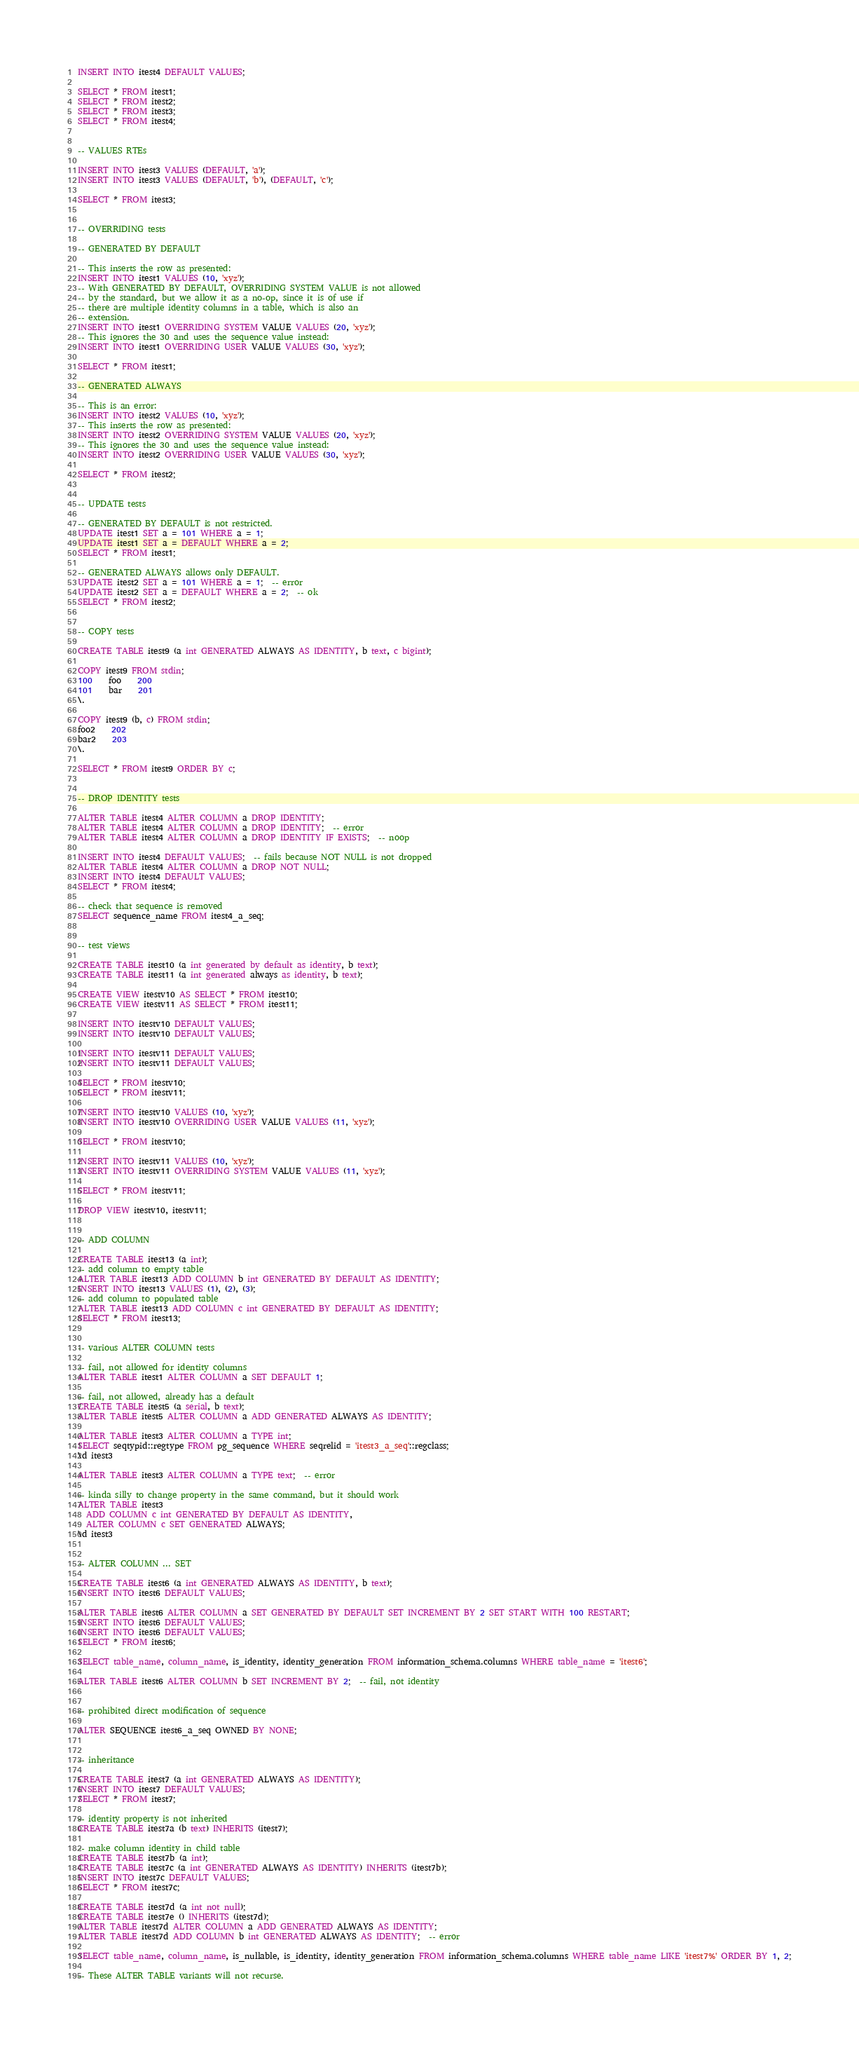<code> <loc_0><loc_0><loc_500><loc_500><_SQL_>INSERT INTO itest4 DEFAULT VALUES;

SELECT * FROM itest1;
SELECT * FROM itest2;
SELECT * FROM itest3;
SELECT * FROM itest4;


-- VALUES RTEs

INSERT INTO itest3 VALUES (DEFAULT, 'a');
INSERT INTO itest3 VALUES (DEFAULT, 'b'), (DEFAULT, 'c');

SELECT * FROM itest3;


-- OVERRIDING tests

-- GENERATED BY DEFAULT

-- This inserts the row as presented:
INSERT INTO itest1 VALUES (10, 'xyz');
-- With GENERATED BY DEFAULT, OVERRIDING SYSTEM VALUE is not allowed
-- by the standard, but we allow it as a no-op, since it is of use if
-- there are multiple identity columns in a table, which is also an
-- extension.
INSERT INTO itest1 OVERRIDING SYSTEM VALUE VALUES (20, 'xyz');
-- This ignores the 30 and uses the sequence value instead:
INSERT INTO itest1 OVERRIDING USER VALUE VALUES (30, 'xyz');

SELECT * FROM itest1;

-- GENERATED ALWAYS

-- This is an error:
INSERT INTO itest2 VALUES (10, 'xyz');
-- This inserts the row as presented:
INSERT INTO itest2 OVERRIDING SYSTEM VALUE VALUES (20, 'xyz');
-- This ignores the 30 and uses the sequence value instead:
INSERT INTO itest2 OVERRIDING USER VALUE VALUES (30, 'xyz');

SELECT * FROM itest2;


-- UPDATE tests

-- GENERATED BY DEFAULT is not restricted.
UPDATE itest1 SET a = 101 WHERE a = 1;
UPDATE itest1 SET a = DEFAULT WHERE a = 2;
SELECT * FROM itest1;

-- GENERATED ALWAYS allows only DEFAULT.
UPDATE itest2 SET a = 101 WHERE a = 1;  -- error
UPDATE itest2 SET a = DEFAULT WHERE a = 2;  -- ok
SELECT * FROM itest2;


-- COPY tests

CREATE TABLE itest9 (a int GENERATED ALWAYS AS IDENTITY, b text, c bigint);

COPY itest9 FROM stdin;
100	foo	200
101	bar	201
\.

COPY itest9 (b, c) FROM stdin;
foo2	202
bar2	203
\.

SELECT * FROM itest9 ORDER BY c;


-- DROP IDENTITY tests

ALTER TABLE itest4 ALTER COLUMN a DROP IDENTITY;
ALTER TABLE itest4 ALTER COLUMN a DROP IDENTITY;  -- error
ALTER TABLE itest4 ALTER COLUMN a DROP IDENTITY IF EXISTS;  -- noop

INSERT INTO itest4 DEFAULT VALUES;  -- fails because NOT NULL is not dropped
ALTER TABLE itest4 ALTER COLUMN a DROP NOT NULL;
INSERT INTO itest4 DEFAULT VALUES;
SELECT * FROM itest4;

-- check that sequence is removed
SELECT sequence_name FROM itest4_a_seq;


-- test views

CREATE TABLE itest10 (a int generated by default as identity, b text);
CREATE TABLE itest11 (a int generated always as identity, b text);

CREATE VIEW itestv10 AS SELECT * FROM itest10;
CREATE VIEW itestv11 AS SELECT * FROM itest11;

INSERT INTO itestv10 DEFAULT VALUES;
INSERT INTO itestv10 DEFAULT VALUES;

INSERT INTO itestv11 DEFAULT VALUES;
INSERT INTO itestv11 DEFAULT VALUES;

SELECT * FROM itestv10;
SELECT * FROM itestv11;

INSERT INTO itestv10 VALUES (10, 'xyz');
INSERT INTO itestv10 OVERRIDING USER VALUE VALUES (11, 'xyz');

SELECT * FROM itestv10;

INSERT INTO itestv11 VALUES (10, 'xyz');
INSERT INTO itestv11 OVERRIDING SYSTEM VALUE VALUES (11, 'xyz');

SELECT * FROM itestv11;

DROP VIEW itestv10, itestv11;


-- ADD COLUMN

CREATE TABLE itest13 (a int);
-- add column to empty table
ALTER TABLE itest13 ADD COLUMN b int GENERATED BY DEFAULT AS IDENTITY;
INSERT INTO itest13 VALUES (1), (2), (3);
-- add column to populated table
ALTER TABLE itest13 ADD COLUMN c int GENERATED BY DEFAULT AS IDENTITY;
SELECT * FROM itest13;


-- various ALTER COLUMN tests

-- fail, not allowed for identity columns
ALTER TABLE itest1 ALTER COLUMN a SET DEFAULT 1;

-- fail, not allowed, already has a default
CREATE TABLE itest5 (a serial, b text);
ALTER TABLE itest5 ALTER COLUMN a ADD GENERATED ALWAYS AS IDENTITY;

ALTER TABLE itest3 ALTER COLUMN a TYPE int;
SELECT seqtypid::regtype FROM pg_sequence WHERE seqrelid = 'itest3_a_seq'::regclass;
\d itest3

ALTER TABLE itest3 ALTER COLUMN a TYPE text;  -- error

-- kinda silly to change property in the same command, but it should work
ALTER TABLE itest3
  ADD COLUMN c int GENERATED BY DEFAULT AS IDENTITY,
  ALTER COLUMN c SET GENERATED ALWAYS;
\d itest3


-- ALTER COLUMN ... SET

CREATE TABLE itest6 (a int GENERATED ALWAYS AS IDENTITY, b text);
INSERT INTO itest6 DEFAULT VALUES;

ALTER TABLE itest6 ALTER COLUMN a SET GENERATED BY DEFAULT SET INCREMENT BY 2 SET START WITH 100 RESTART;
INSERT INTO itest6 DEFAULT VALUES;
INSERT INTO itest6 DEFAULT VALUES;
SELECT * FROM itest6;

SELECT table_name, column_name, is_identity, identity_generation FROM information_schema.columns WHERE table_name = 'itest6';

ALTER TABLE itest6 ALTER COLUMN b SET INCREMENT BY 2;  -- fail, not identity


-- prohibited direct modification of sequence

ALTER SEQUENCE itest6_a_seq OWNED BY NONE;


-- inheritance

CREATE TABLE itest7 (a int GENERATED ALWAYS AS IDENTITY);
INSERT INTO itest7 DEFAULT VALUES;
SELECT * FROM itest7;

-- identity property is not inherited
CREATE TABLE itest7a (b text) INHERITS (itest7);

-- make column identity in child table
CREATE TABLE itest7b (a int);
CREATE TABLE itest7c (a int GENERATED ALWAYS AS IDENTITY) INHERITS (itest7b);
INSERT INTO itest7c DEFAULT VALUES;
SELECT * FROM itest7c;

CREATE TABLE itest7d (a int not null);
CREATE TABLE itest7e () INHERITS (itest7d);
ALTER TABLE itest7d ALTER COLUMN a ADD GENERATED ALWAYS AS IDENTITY;
ALTER TABLE itest7d ADD COLUMN b int GENERATED ALWAYS AS IDENTITY;  -- error

SELECT table_name, column_name, is_nullable, is_identity, identity_generation FROM information_schema.columns WHERE table_name LIKE 'itest7%' ORDER BY 1, 2;

-- These ALTER TABLE variants will not recurse.</code> 